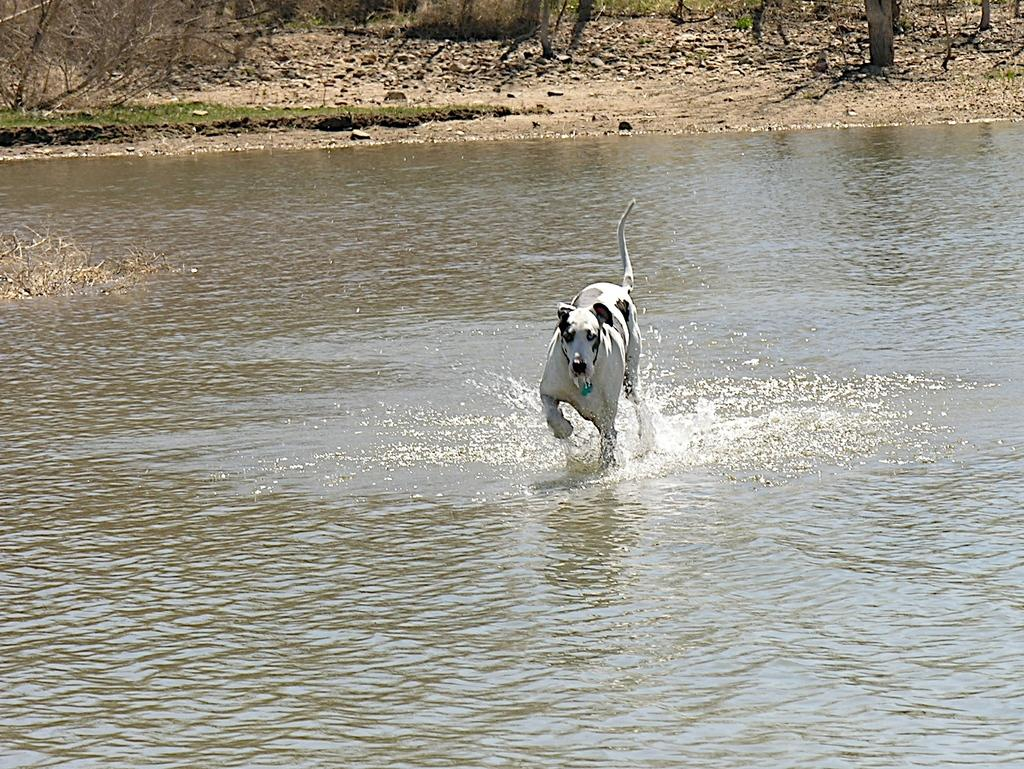What animal is present in the image? There is a dog in the image. Where is the dog located? The dog is on the water. What can be seen in the background of the image? There are trees in the background of the image. What type of scarecrow is standing near the dog in the image? There is no scarecrow present in the image; it features a dog on the water with trees in the background. 